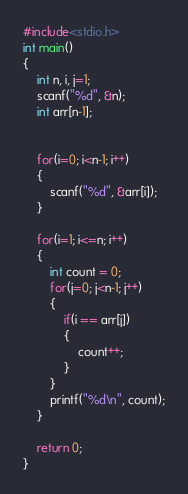<code> <loc_0><loc_0><loc_500><loc_500><_C_>#include<stdio.h>
int main()
{
    int n, i, j=1;
    scanf("%d", &n);
    int arr[n-1];


    for(i=0; i<n-1; i++)
    {
        scanf("%d", &arr[i]);
    }

    for(i=1; i<=n; i++)
    {
        int count = 0;
        for(j=0; j<n-1; j++)
        {
            if(i == arr[j])
            {
                count++;
            }
        }
        printf("%d\n", count);
    }

    return 0;
}
</code> 